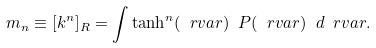<formula> <loc_0><loc_0><loc_500><loc_500>m _ { n } \equiv [ k ^ { n } ] _ { R } = \int \tanh ^ { n } ( \ r v a r ) \ P ( \ r v a r ) \ d \ r v a r .</formula> 